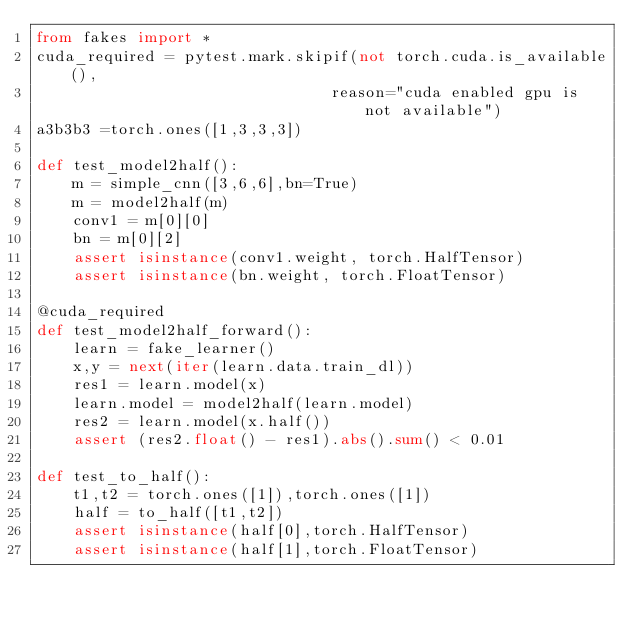Convert code to text. <code><loc_0><loc_0><loc_500><loc_500><_Python_>from fakes import *
cuda_required = pytest.mark.skipif(not torch.cuda.is_available(),
                                reason="cuda enabled gpu is not available")
a3b3b3 =torch.ones([1,3,3,3])

def test_model2half():
    m = simple_cnn([3,6,6],bn=True)
    m = model2half(m)
    conv1 = m[0][0]
    bn = m[0][2]
    assert isinstance(conv1.weight, torch.HalfTensor)
    assert isinstance(bn.weight, torch.FloatTensor)

@cuda_required
def test_model2half_forward():
    learn = fake_learner()
    x,y = next(iter(learn.data.train_dl))
    res1 = learn.model(x)
    learn.model = model2half(learn.model)
    res2 = learn.model(x.half())
    assert (res2.float() - res1).abs().sum() < 0.01

def test_to_half():
    t1,t2 = torch.ones([1]),torch.ones([1])
    half = to_half([t1,t2])
    assert isinstance(half[0],torch.HalfTensor)
    assert isinstance(half[1],torch.FloatTensor)
</code> 